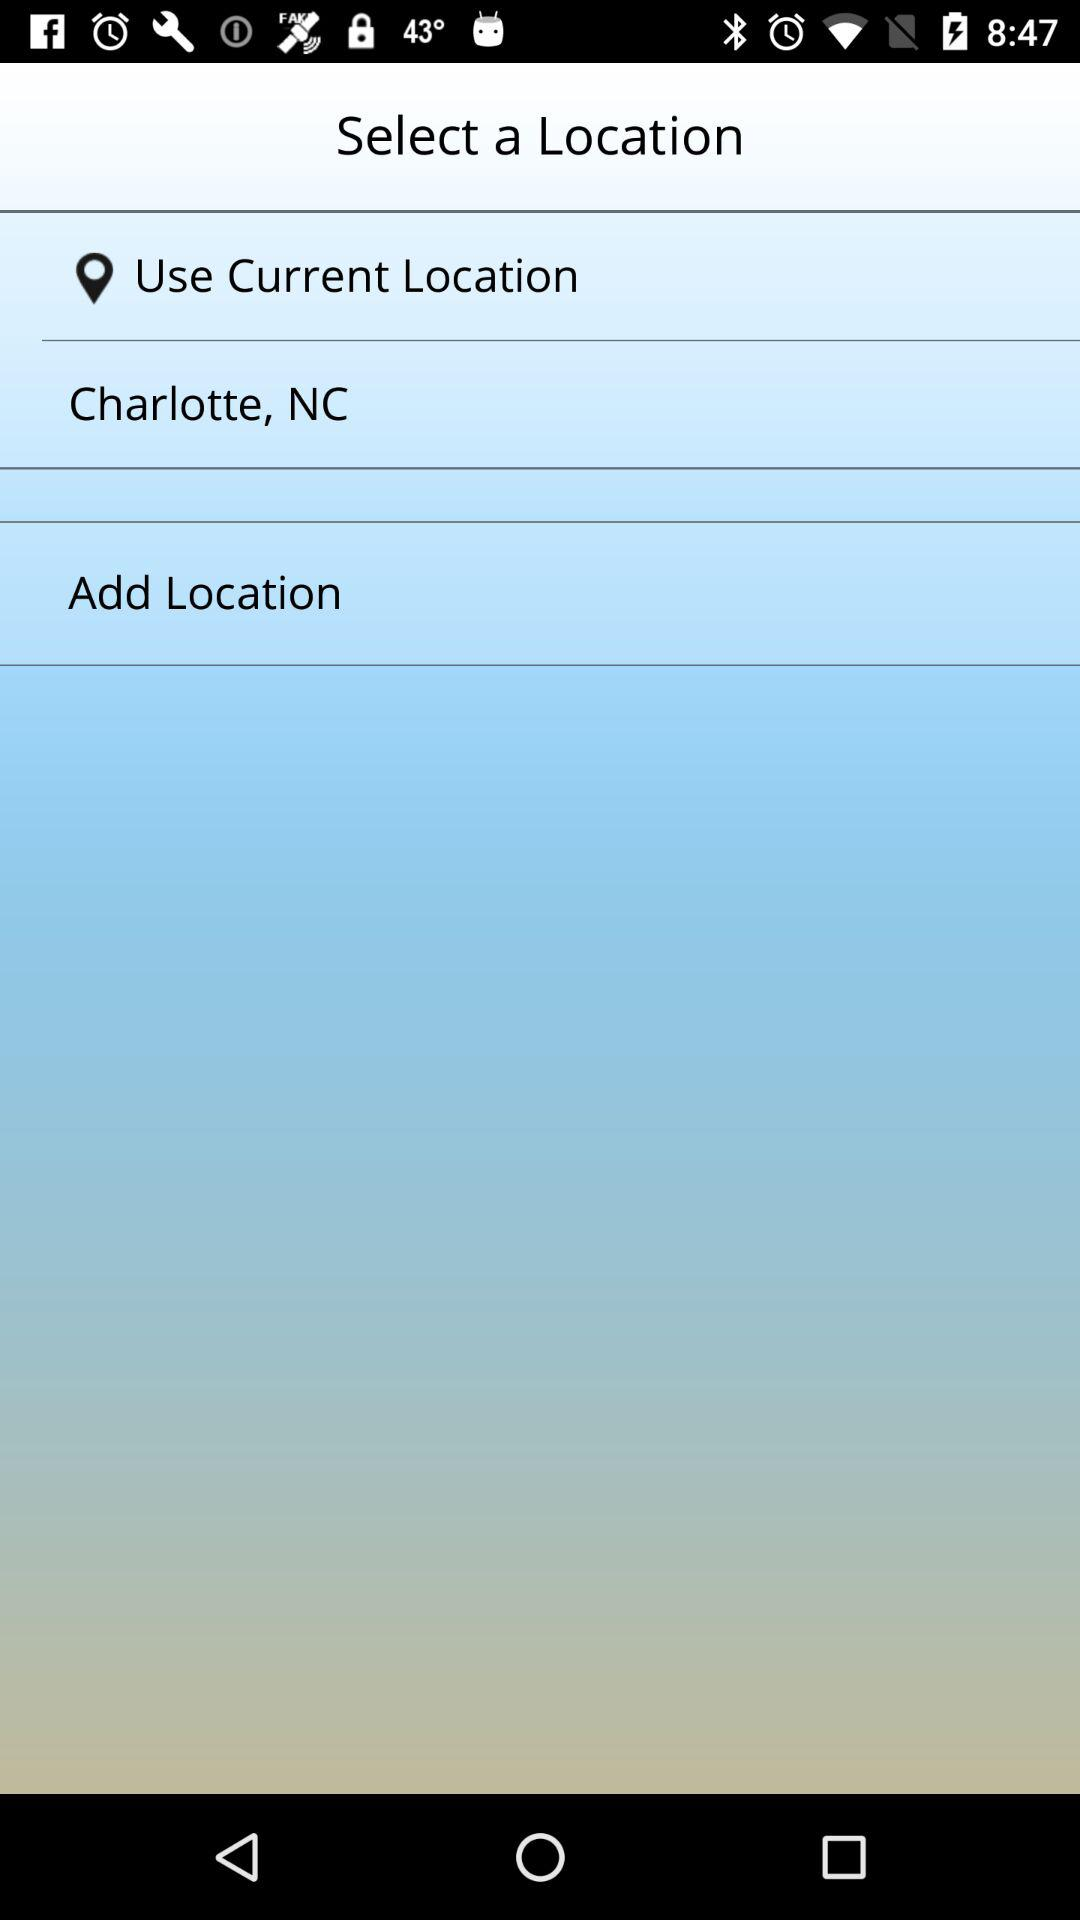What is the mentioned location? The mentioned location is "Charlotte, NC". 